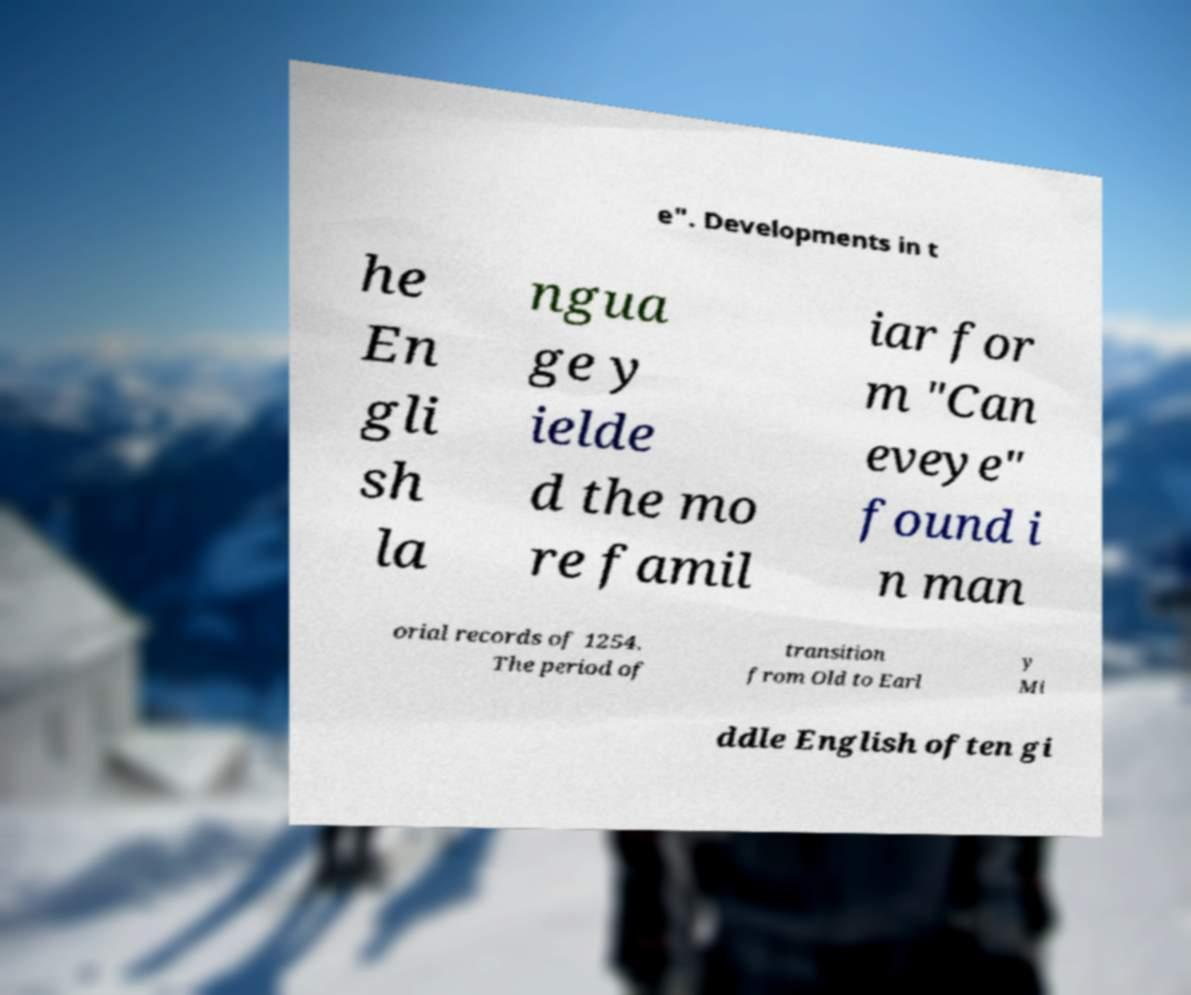For documentation purposes, I need the text within this image transcribed. Could you provide that? e". Developments in t he En gli sh la ngua ge y ielde d the mo re famil iar for m "Can eveye" found i n man orial records of 1254. The period of transition from Old to Earl y Mi ddle English often gi 